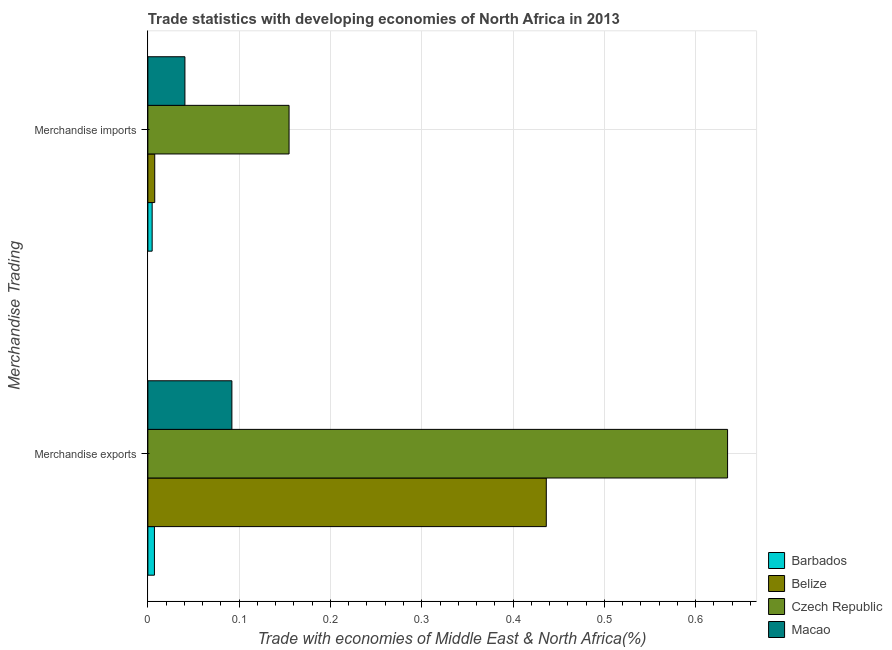How many different coloured bars are there?
Provide a short and direct response. 4. Are the number of bars per tick equal to the number of legend labels?
Your answer should be compact. Yes. Are the number of bars on each tick of the Y-axis equal?
Your response must be concise. Yes. How many bars are there on the 1st tick from the top?
Provide a short and direct response. 4. How many bars are there on the 1st tick from the bottom?
Your response must be concise. 4. What is the label of the 2nd group of bars from the top?
Your response must be concise. Merchandise exports. What is the merchandise imports in Belize?
Your response must be concise. 0.01. Across all countries, what is the maximum merchandise imports?
Ensure brevity in your answer.  0.15. Across all countries, what is the minimum merchandise imports?
Make the answer very short. 0. In which country was the merchandise imports maximum?
Your answer should be compact. Czech Republic. In which country was the merchandise exports minimum?
Your answer should be compact. Barbados. What is the total merchandise exports in the graph?
Make the answer very short. 1.17. What is the difference between the merchandise imports in Czech Republic and that in Macao?
Give a very brief answer. 0.11. What is the difference between the merchandise imports in Czech Republic and the merchandise exports in Belize?
Offer a terse response. -0.28. What is the average merchandise imports per country?
Your answer should be very brief. 0.05. What is the difference between the merchandise exports and merchandise imports in Belize?
Your answer should be very brief. 0.43. In how many countries, is the merchandise exports greater than 0.38000000000000006 %?
Provide a short and direct response. 2. What is the ratio of the merchandise imports in Barbados to that in Belize?
Offer a very short reply. 0.62. Is the merchandise imports in Belize less than that in Barbados?
Give a very brief answer. No. What does the 1st bar from the top in Merchandise imports represents?
Offer a very short reply. Macao. What does the 3rd bar from the bottom in Merchandise imports represents?
Provide a short and direct response. Czech Republic. How many bars are there?
Offer a very short reply. 8. Are all the bars in the graph horizontal?
Your answer should be very brief. Yes. What is the difference between two consecutive major ticks on the X-axis?
Provide a succinct answer. 0.1. Are the values on the major ticks of X-axis written in scientific E-notation?
Provide a succinct answer. No. Does the graph contain any zero values?
Provide a succinct answer. No. Where does the legend appear in the graph?
Your answer should be compact. Bottom right. How many legend labels are there?
Give a very brief answer. 4. What is the title of the graph?
Ensure brevity in your answer.  Trade statistics with developing economies of North Africa in 2013. What is the label or title of the X-axis?
Ensure brevity in your answer.  Trade with economies of Middle East & North Africa(%). What is the label or title of the Y-axis?
Provide a succinct answer. Merchandise Trading. What is the Trade with economies of Middle East & North Africa(%) of Barbados in Merchandise exports?
Ensure brevity in your answer.  0.01. What is the Trade with economies of Middle East & North Africa(%) of Belize in Merchandise exports?
Offer a terse response. 0.44. What is the Trade with economies of Middle East & North Africa(%) of Czech Republic in Merchandise exports?
Make the answer very short. 0.64. What is the Trade with economies of Middle East & North Africa(%) in Macao in Merchandise exports?
Offer a very short reply. 0.09. What is the Trade with economies of Middle East & North Africa(%) of Barbados in Merchandise imports?
Ensure brevity in your answer.  0. What is the Trade with economies of Middle East & North Africa(%) in Belize in Merchandise imports?
Your answer should be very brief. 0.01. What is the Trade with economies of Middle East & North Africa(%) in Czech Republic in Merchandise imports?
Your answer should be very brief. 0.15. What is the Trade with economies of Middle East & North Africa(%) in Macao in Merchandise imports?
Provide a short and direct response. 0.04. Across all Merchandise Trading, what is the maximum Trade with economies of Middle East & North Africa(%) in Barbados?
Offer a terse response. 0.01. Across all Merchandise Trading, what is the maximum Trade with economies of Middle East & North Africa(%) of Belize?
Give a very brief answer. 0.44. Across all Merchandise Trading, what is the maximum Trade with economies of Middle East & North Africa(%) of Czech Republic?
Give a very brief answer. 0.64. Across all Merchandise Trading, what is the maximum Trade with economies of Middle East & North Africa(%) in Macao?
Provide a short and direct response. 0.09. Across all Merchandise Trading, what is the minimum Trade with economies of Middle East & North Africa(%) of Barbados?
Provide a succinct answer. 0. Across all Merchandise Trading, what is the minimum Trade with economies of Middle East & North Africa(%) of Belize?
Give a very brief answer. 0.01. Across all Merchandise Trading, what is the minimum Trade with economies of Middle East & North Africa(%) of Czech Republic?
Offer a very short reply. 0.15. Across all Merchandise Trading, what is the minimum Trade with economies of Middle East & North Africa(%) of Macao?
Give a very brief answer. 0.04. What is the total Trade with economies of Middle East & North Africa(%) of Barbados in the graph?
Keep it short and to the point. 0.01. What is the total Trade with economies of Middle East & North Africa(%) of Belize in the graph?
Give a very brief answer. 0.44. What is the total Trade with economies of Middle East & North Africa(%) of Czech Republic in the graph?
Provide a short and direct response. 0.79. What is the total Trade with economies of Middle East & North Africa(%) of Macao in the graph?
Keep it short and to the point. 0.13. What is the difference between the Trade with economies of Middle East & North Africa(%) in Barbados in Merchandise exports and that in Merchandise imports?
Your response must be concise. 0. What is the difference between the Trade with economies of Middle East & North Africa(%) in Belize in Merchandise exports and that in Merchandise imports?
Ensure brevity in your answer.  0.43. What is the difference between the Trade with economies of Middle East & North Africa(%) of Czech Republic in Merchandise exports and that in Merchandise imports?
Make the answer very short. 0.48. What is the difference between the Trade with economies of Middle East & North Africa(%) of Macao in Merchandise exports and that in Merchandise imports?
Provide a succinct answer. 0.05. What is the difference between the Trade with economies of Middle East & North Africa(%) in Barbados in Merchandise exports and the Trade with economies of Middle East & North Africa(%) in Belize in Merchandise imports?
Your answer should be compact. -0. What is the difference between the Trade with economies of Middle East & North Africa(%) in Barbados in Merchandise exports and the Trade with economies of Middle East & North Africa(%) in Czech Republic in Merchandise imports?
Ensure brevity in your answer.  -0.15. What is the difference between the Trade with economies of Middle East & North Africa(%) of Barbados in Merchandise exports and the Trade with economies of Middle East & North Africa(%) of Macao in Merchandise imports?
Offer a terse response. -0.03. What is the difference between the Trade with economies of Middle East & North Africa(%) of Belize in Merchandise exports and the Trade with economies of Middle East & North Africa(%) of Czech Republic in Merchandise imports?
Provide a short and direct response. 0.28. What is the difference between the Trade with economies of Middle East & North Africa(%) in Belize in Merchandise exports and the Trade with economies of Middle East & North Africa(%) in Macao in Merchandise imports?
Ensure brevity in your answer.  0.4. What is the difference between the Trade with economies of Middle East & North Africa(%) in Czech Republic in Merchandise exports and the Trade with economies of Middle East & North Africa(%) in Macao in Merchandise imports?
Ensure brevity in your answer.  0.59. What is the average Trade with economies of Middle East & North Africa(%) of Barbados per Merchandise Trading?
Keep it short and to the point. 0.01. What is the average Trade with economies of Middle East & North Africa(%) in Belize per Merchandise Trading?
Offer a terse response. 0.22. What is the average Trade with economies of Middle East & North Africa(%) in Czech Republic per Merchandise Trading?
Your answer should be compact. 0.39. What is the average Trade with economies of Middle East & North Africa(%) of Macao per Merchandise Trading?
Make the answer very short. 0.07. What is the difference between the Trade with economies of Middle East & North Africa(%) of Barbados and Trade with economies of Middle East & North Africa(%) of Belize in Merchandise exports?
Provide a short and direct response. -0.43. What is the difference between the Trade with economies of Middle East & North Africa(%) of Barbados and Trade with economies of Middle East & North Africa(%) of Czech Republic in Merchandise exports?
Make the answer very short. -0.63. What is the difference between the Trade with economies of Middle East & North Africa(%) of Barbados and Trade with economies of Middle East & North Africa(%) of Macao in Merchandise exports?
Give a very brief answer. -0.08. What is the difference between the Trade with economies of Middle East & North Africa(%) of Belize and Trade with economies of Middle East & North Africa(%) of Czech Republic in Merchandise exports?
Make the answer very short. -0.2. What is the difference between the Trade with economies of Middle East & North Africa(%) in Belize and Trade with economies of Middle East & North Africa(%) in Macao in Merchandise exports?
Your response must be concise. 0.34. What is the difference between the Trade with economies of Middle East & North Africa(%) in Czech Republic and Trade with economies of Middle East & North Africa(%) in Macao in Merchandise exports?
Your answer should be compact. 0.54. What is the difference between the Trade with economies of Middle East & North Africa(%) of Barbados and Trade with economies of Middle East & North Africa(%) of Belize in Merchandise imports?
Offer a very short reply. -0. What is the difference between the Trade with economies of Middle East & North Africa(%) in Barbados and Trade with economies of Middle East & North Africa(%) in Macao in Merchandise imports?
Offer a terse response. -0.04. What is the difference between the Trade with economies of Middle East & North Africa(%) in Belize and Trade with economies of Middle East & North Africa(%) in Czech Republic in Merchandise imports?
Your answer should be very brief. -0.15. What is the difference between the Trade with economies of Middle East & North Africa(%) of Belize and Trade with economies of Middle East & North Africa(%) of Macao in Merchandise imports?
Your response must be concise. -0.03. What is the difference between the Trade with economies of Middle East & North Africa(%) in Czech Republic and Trade with economies of Middle East & North Africa(%) in Macao in Merchandise imports?
Give a very brief answer. 0.11. What is the ratio of the Trade with economies of Middle East & North Africa(%) of Barbados in Merchandise exports to that in Merchandise imports?
Your response must be concise. 1.53. What is the ratio of the Trade with economies of Middle East & North Africa(%) of Belize in Merchandise exports to that in Merchandise imports?
Make the answer very short. 58.03. What is the ratio of the Trade with economies of Middle East & North Africa(%) in Czech Republic in Merchandise exports to that in Merchandise imports?
Your response must be concise. 4.11. What is the ratio of the Trade with economies of Middle East & North Africa(%) of Macao in Merchandise exports to that in Merchandise imports?
Ensure brevity in your answer.  2.27. What is the difference between the highest and the second highest Trade with economies of Middle East & North Africa(%) in Barbados?
Your answer should be very brief. 0. What is the difference between the highest and the second highest Trade with economies of Middle East & North Africa(%) of Belize?
Offer a terse response. 0.43. What is the difference between the highest and the second highest Trade with economies of Middle East & North Africa(%) of Czech Republic?
Offer a very short reply. 0.48. What is the difference between the highest and the second highest Trade with economies of Middle East & North Africa(%) of Macao?
Make the answer very short. 0.05. What is the difference between the highest and the lowest Trade with economies of Middle East & North Africa(%) in Barbados?
Your answer should be compact. 0. What is the difference between the highest and the lowest Trade with economies of Middle East & North Africa(%) in Belize?
Your response must be concise. 0.43. What is the difference between the highest and the lowest Trade with economies of Middle East & North Africa(%) of Czech Republic?
Provide a short and direct response. 0.48. What is the difference between the highest and the lowest Trade with economies of Middle East & North Africa(%) in Macao?
Your answer should be compact. 0.05. 